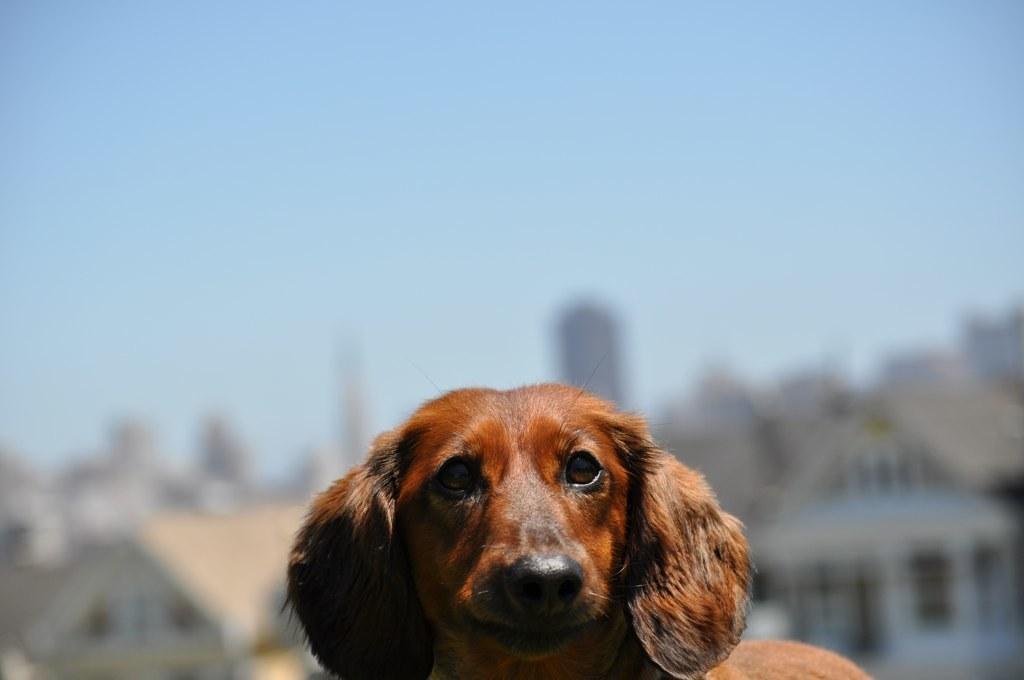How would you summarize this image in a sentence or two? This image consists of a dog in brown color. In the background, there are buildings. And the background is blurred. 